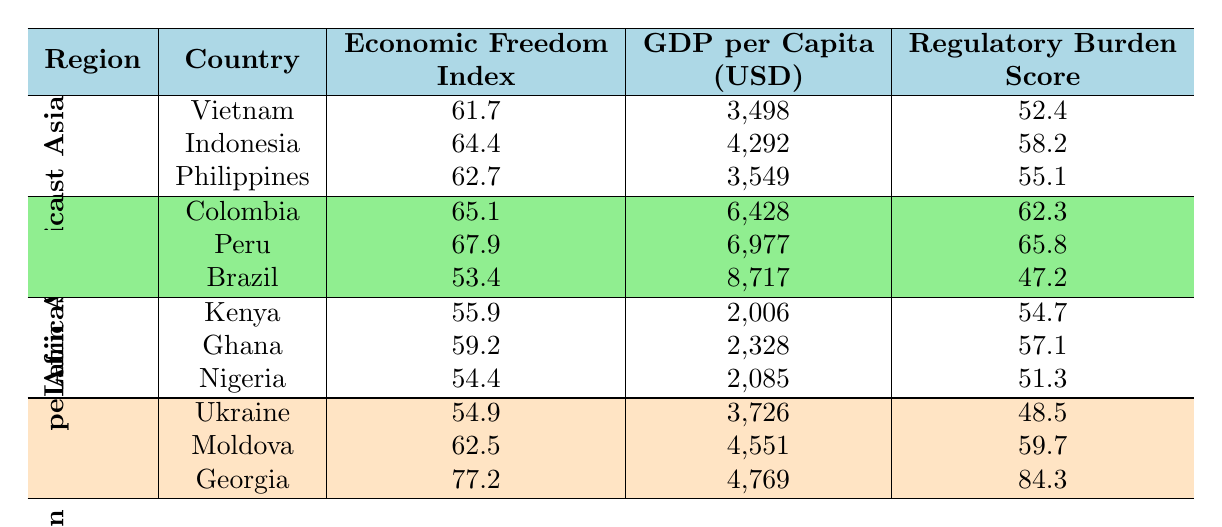What is the highest Economic Freedom Index among the countries listed in Southeast Asia? In the Southeast Asia section, comparing the Economic Freedom Indices: Vietnam has 61.7, Indonesia has 64.4, and the Philippines has 62.7. The highest value is 64.4 for Indonesia.
Answer: 64.4 Which country in Latin America has the lowest GDP per Capita? In the Latin America section, we have Colombia at 6428, Peru at 6977, and Brazil at 8717. Brazil has the highest GDP per Capita, while Colombia has the lowest at 6428.
Answer: 6428 Calculate the average Regulatory Burden Score for countries in Africa. The Regulatory Burden Scores for the African countries are Kenya (54.7), Ghana (57.1), and Nigeria (51.3). Adding them gives us 54.7 + 57.1 + 51.3 = 163.1. Dividing by the number of countries (3) gives us an average of 163.1 / 3 = 54.37.
Answer: 54.37 Is there a direct correlation between the Economic Freedom Index and GDP per Capita for developing nations in Latin America? Analyzing the Latin America data, Colombia has an Economic Freedom Index of 65.1 and a GDP per Capita of 6428, while Peru (67.9, 6977) has a higher index and higher GDP, and Brazil has a low Economic Freedom Index of 53.4 but the highest GDP per Capita of 8717. This suggests a mixed relationship, indicating a complicated correlation rather than a direct one.
Answer: No Which region has the highest average GDP per Capita from the countries listed? Calculating the GDP per Capita averages: Southeast Asia: (3498 + 4292 + 3549) / 3 = 3779.67; Latin America: (6428 + 6977 + 8717) / 3 = 7360.67; Africa: (2006 + 2328 + 2085) / 3 = 2139.67; Eastern Europe: (3726 + 4551 + 4769) / 3 = 4348.67. Latin America has the highest average GDP per Capita at 7360.67.
Answer: Latin America Which country has the highest Tax Burden Score and what is that score? Looking through the Tax Burden Scores, Vietnam has 79.5, Indonesia has 83.7, Philippines has 78.9, Colombia has 71.4, Peru has 80.5, Brazil has 70.1, Kenya has 79.3, Ghana has 82.6, Nigeria has 84.2, Ukraine has 81.8, Moldova has 85.4, and Georgia has 89.1. Georgia has the highest score of 89.1.
Answer: 89.1 Does the Economic Freedom Index show a trend of improvement with increasing GDP per Capita across all regions? The data presents varied situations; for example, Brazil has a low Economic Freedom Index yet high GDP per Capita, while Georgia shows the opposite. This indicates there isn’t a consistent trend across all regions like a direct improvement. Therefore, it's concluded that no general trend is observable across all regions.
Answer: No 